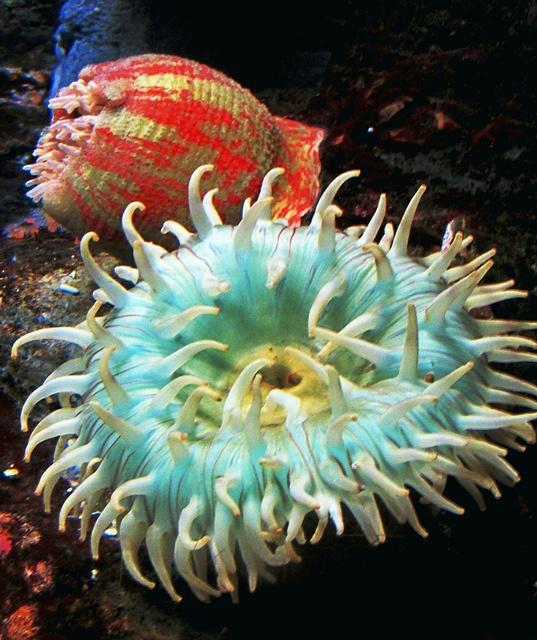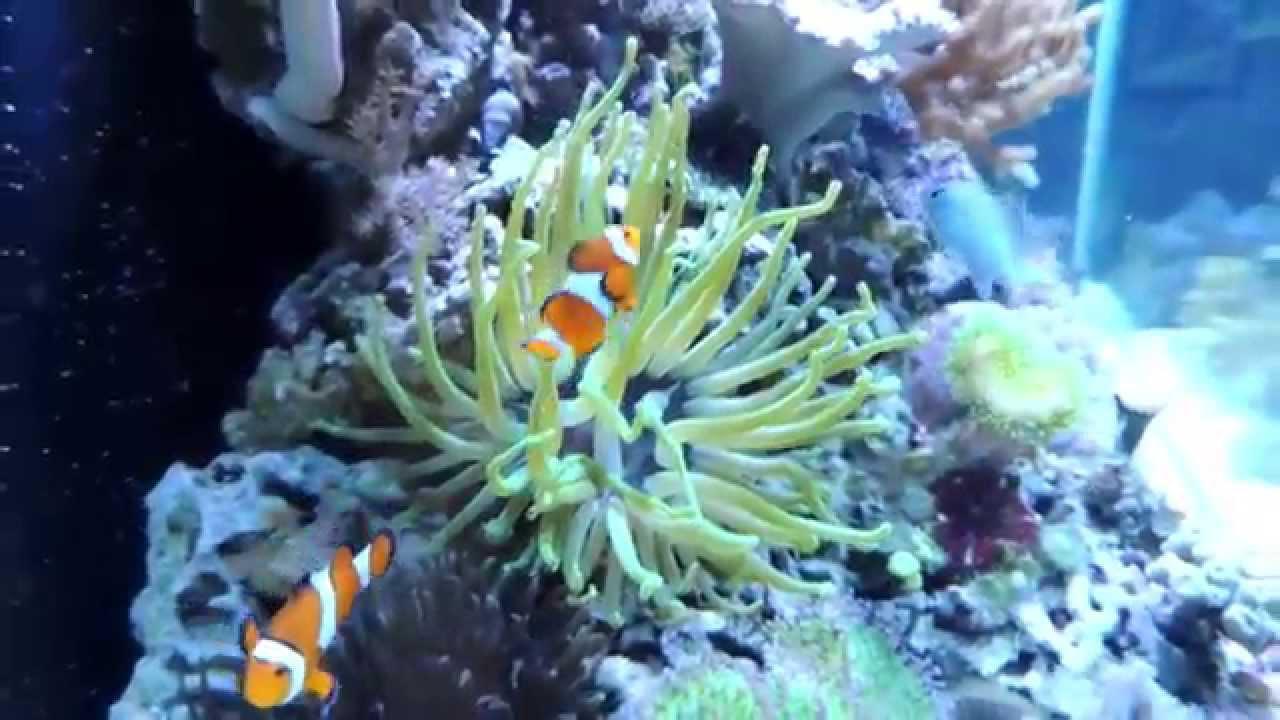The first image is the image on the left, the second image is the image on the right. For the images displayed, is the sentence "At least one of the images contains an orange and white fish." factually correct? Answer yes or no. Yes. The first image is the image on the left, the second image is the image on the right. For the images shown, is this caption "Striped clownfish are swimming in one image of an anemone." true? Answer yes or no. Yes. 